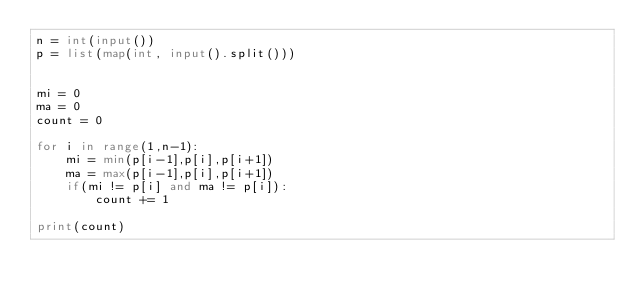<code> <loc_0><loc_0><loc_500><loc_500><_Python_>n = int(input())
p = list(map(int, input().split()))


mi = 0
ma = 0
count = 0

for i in range(1,n-1):
    mi = min(p[i-1],p[i],p[i+1])
    ma = max(p[i-1],p[i],p[i+1])
    if(mi != p[i] and ma != p[i]):
        count += 1

print(count)
</code> 